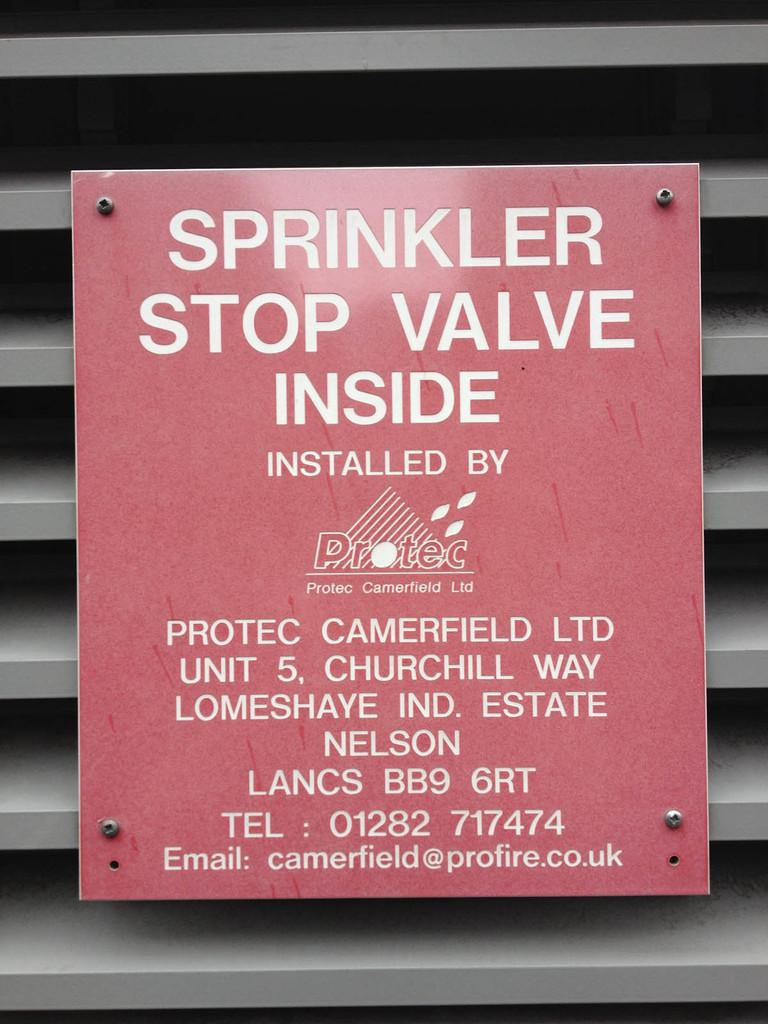<image>
Write a terse but informative summary of the picture. A red sign that says Sprinkler Stop valve inside. 